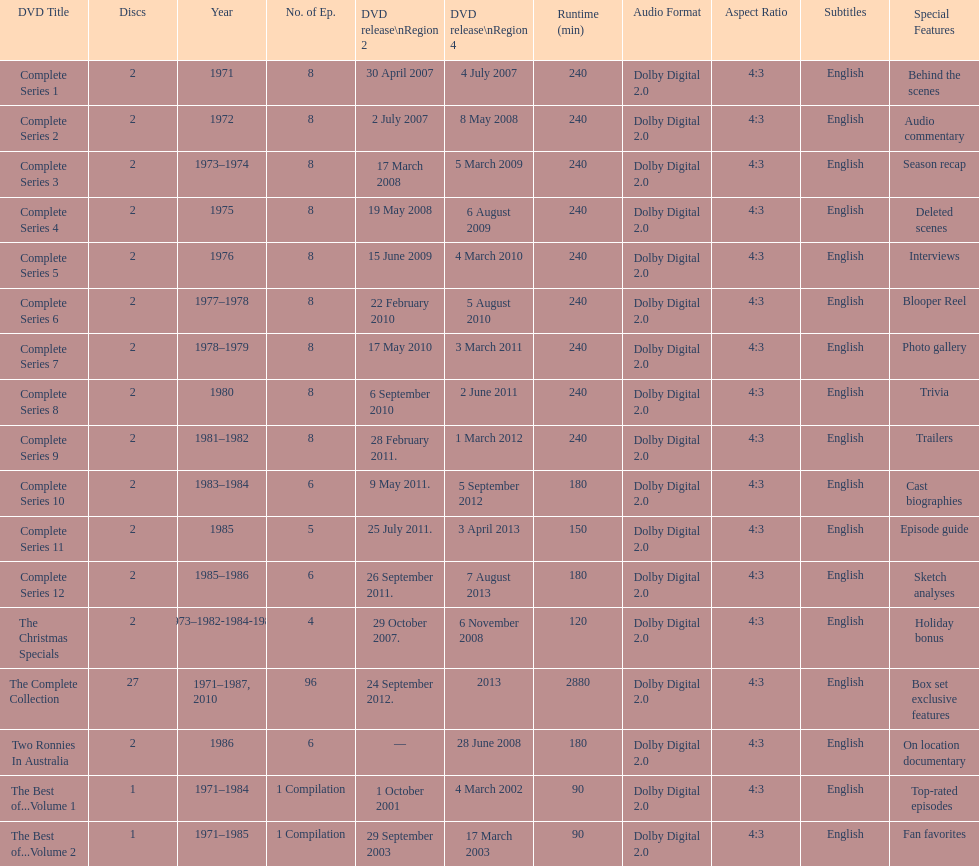How many series had 8 episodes? 9. 